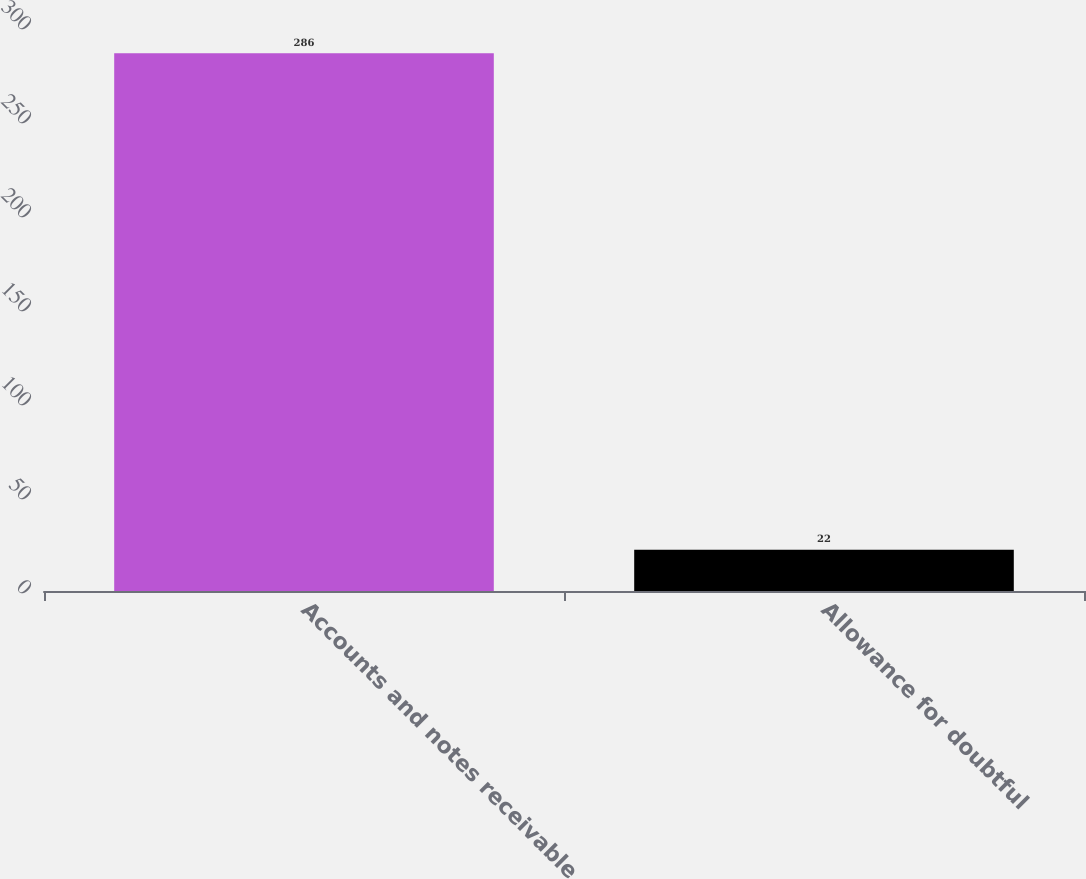Convert chart to OTSL. <chart><loc_0><loc_0><loc_500><loc_500><bar_chart><fcel>Accounts and notes receivable<fcel>Allowance for doubtful<nl><fcel>286<fcel>22<nl></chart> 